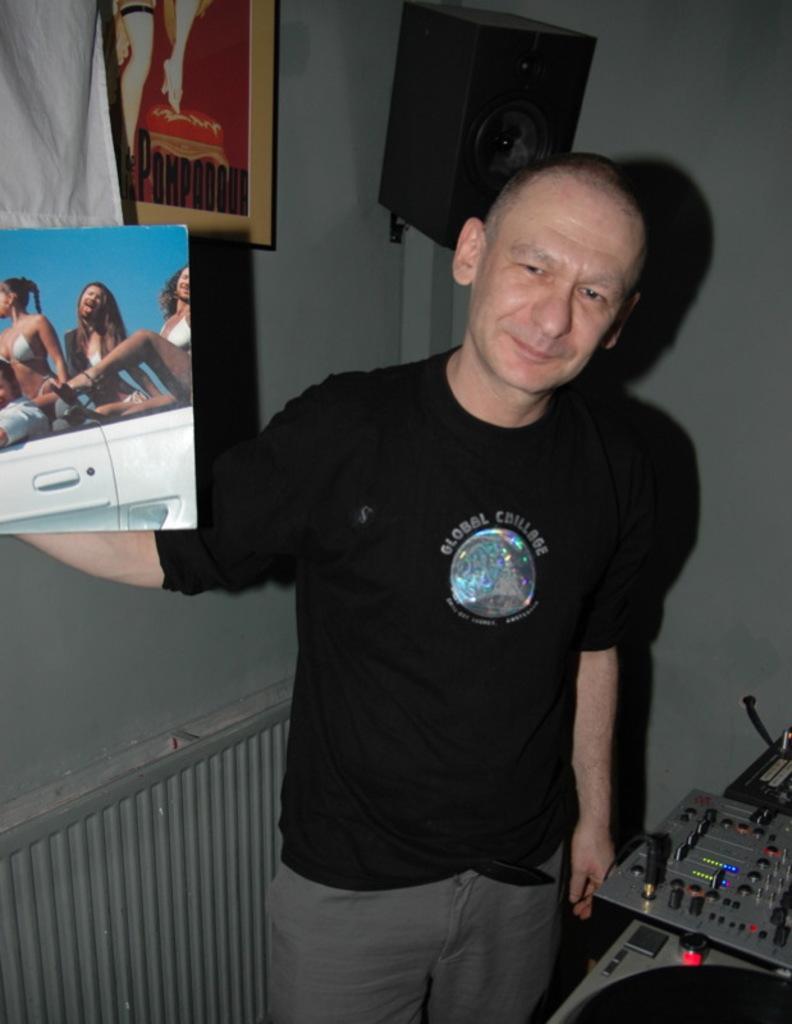Describe this image in one or two sentences. In this picture there is a man who is wearing black t-shirt and trouser. He is holding the book. He is standing near to the table. On the table we can see keyboard and musical instruments. In this book we can see a women's picture. On the top there is a speaker near to the photo frame. On the top left corner there is a white cloth. 